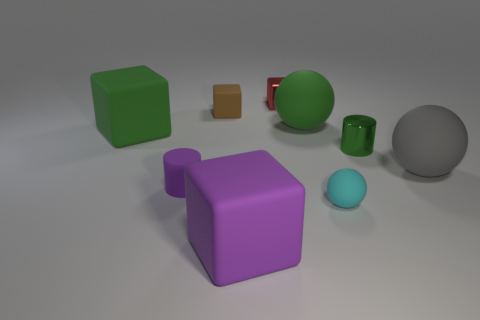There is a matte ball behind the big rubber object that is right of the big green thing that is right of the purple cylinder; what color is it?
Your answer should be compact. Green. Is the color of the metal block on the right side of the tiny brown rubber block the same as the matte cylinder?
Give a very brief answer. No. What number of other things are there of the same color as the shiny cylinder?
Your response must be concise. 2. How many objects are small red rubber blocks or metallic things?
Make the answer very short. 2. How many objects are either tiny cyan rubber balls or small matte objects to the left of the purple rubber block?
Your answer should be compact. 3. Do the purple cylinder and the large purple object have the same material?
Provide a succinct answer. Yes. How many other things are there of the same material as the cyan sphere?
Provide a succinct answer. 6. Is the number of purple cylinders greater than the number of tiny blocks?
Your response must be concise. No. Does the big green object on the right side of the green block have the same shape as the gray matte object?
Your answer should be compact. Yes. Are there fewer blue rubber blocks than cubes?
Your response must be concise. Yes. 